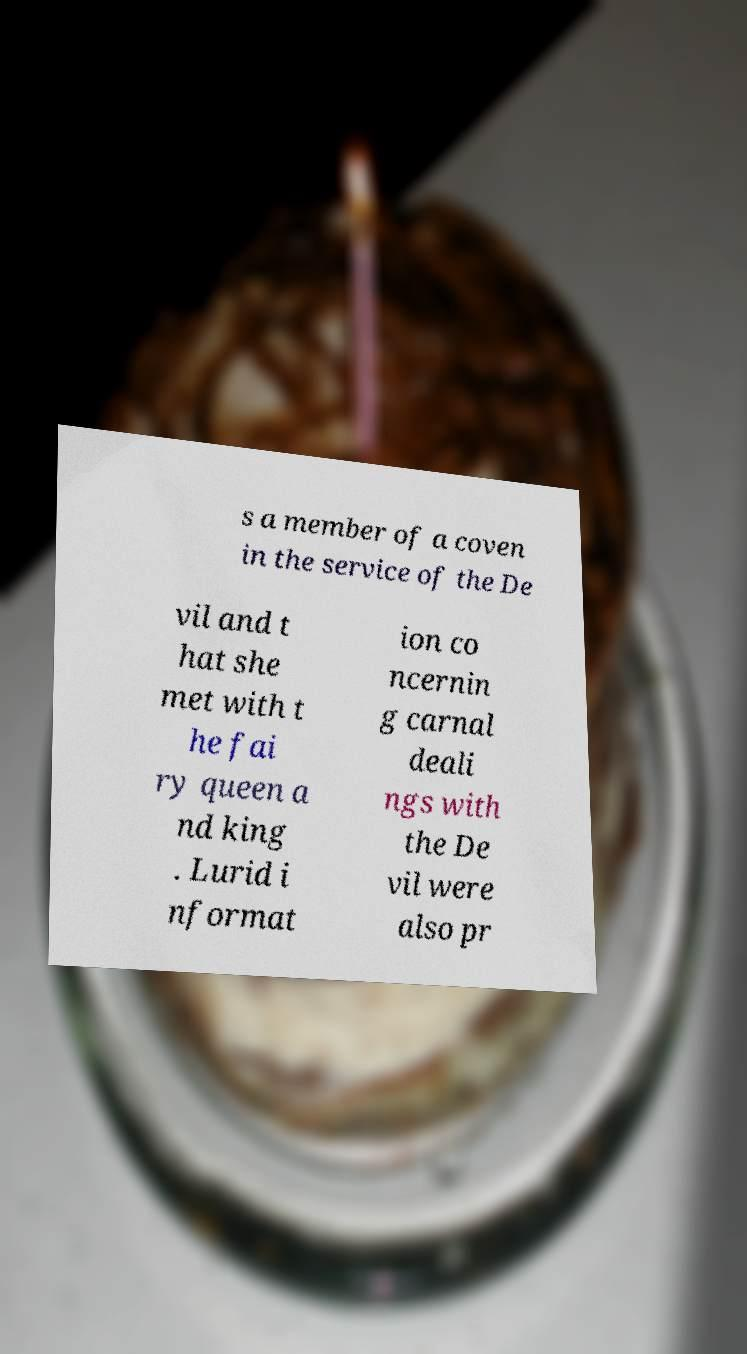Can you accurately transcribe the text from the provided image for me? s a member of a coven in the service of the De vil and t hat she met with t he fai ry queen a nd king . Lurid i nformat ion co ncernin g carnal deali ngs with the De vil were also pr 